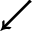<formula> <loc_0><loc_0><loc_500><loc_500>\swarrow</formula> 